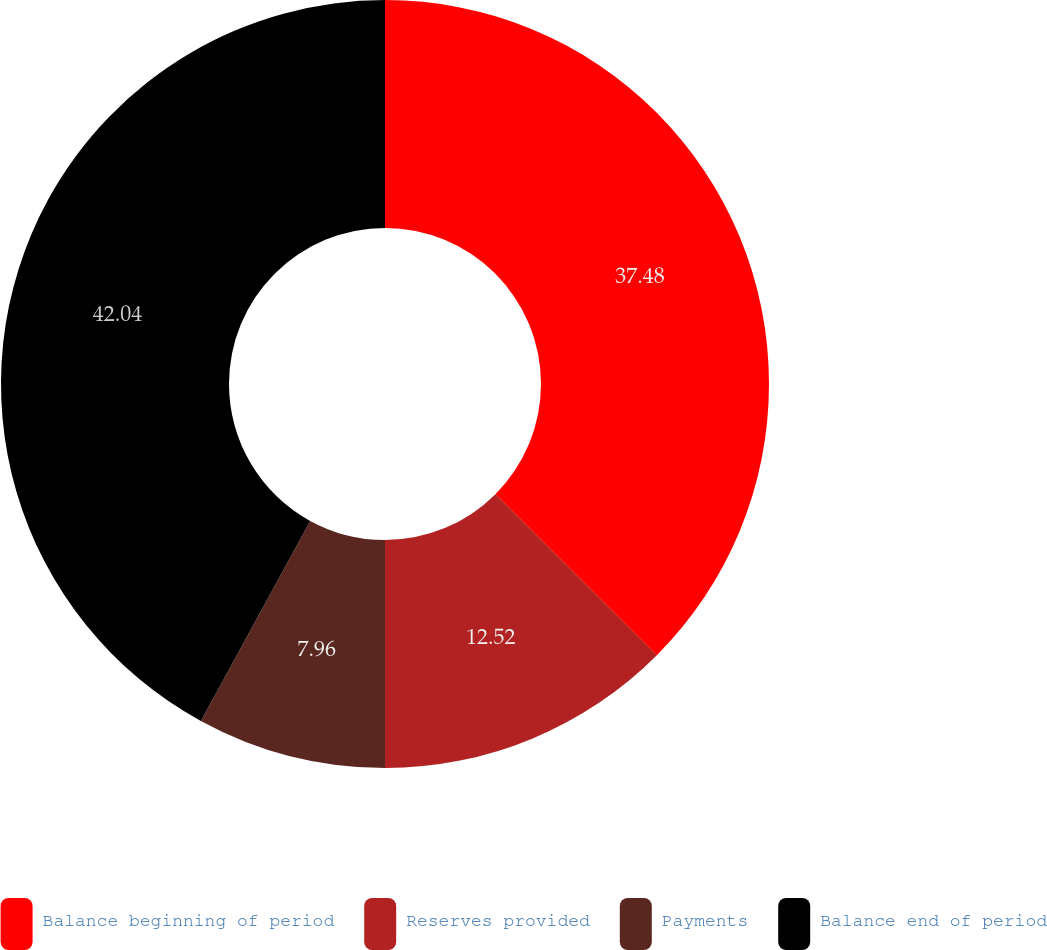Convert chart to OTSL. <chart><loc_0><loc_0><loc_500><loc_500><pie_chart><fcel>Balance beginning of period<fcel>Reserves provided<fcel>Payments<fcel>Balance end of period<nl><fcel>37.48%<fcel>12.52%<fcel>7.96%<fcel>42.04%<nl></chart> 